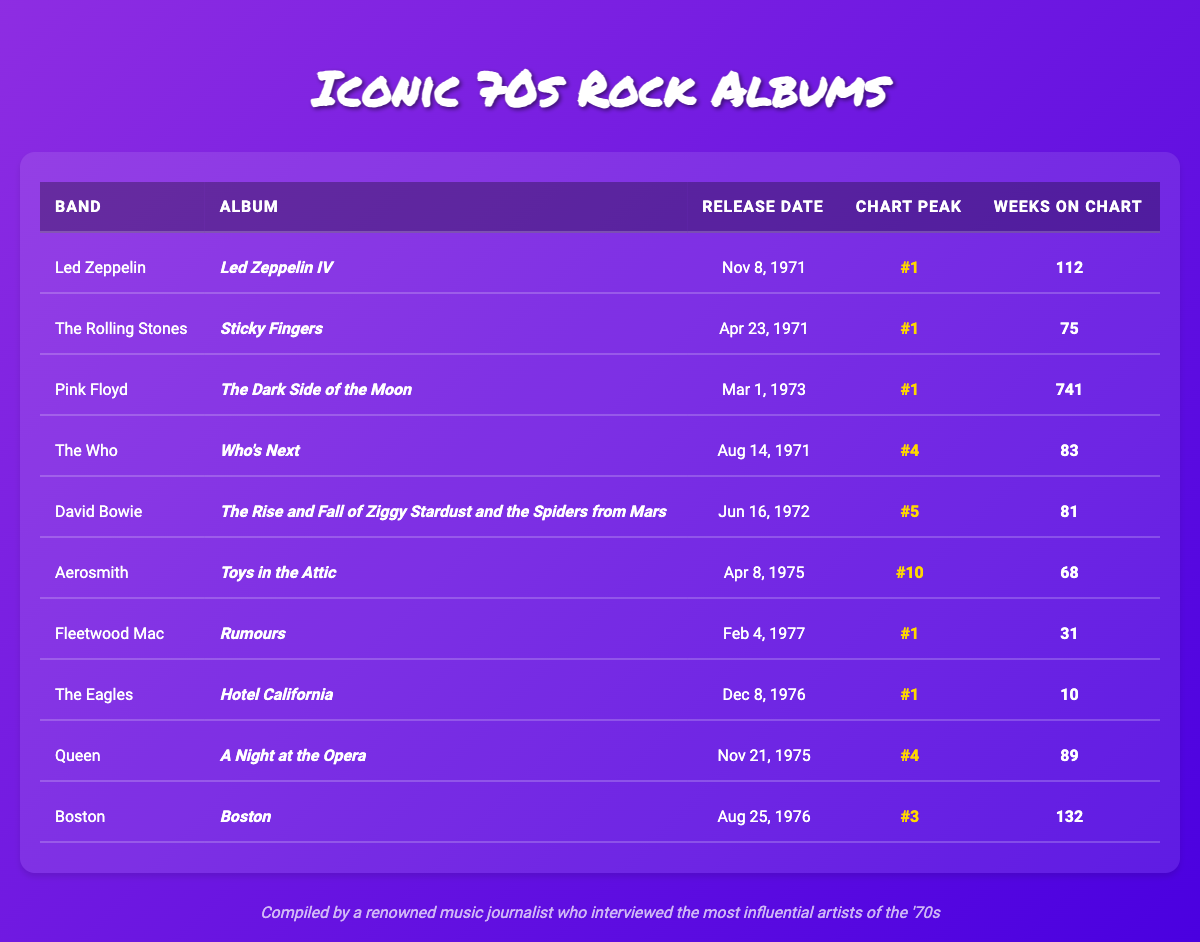What was the release date of Pink Floyd's album "The Dark Side of the Moon"? According to the table, the release date for Pink Floyd's album "The Dark Side of the Moon" is listed as March 1, 1973.
Answer: March 1, 1973 Which album stayed the longest on the charts? The table shows that Pink Floyd's "The Dark Side of the Moon" stayed on the charts for a total of 741 weeks, which is significantly longer than any other album listed.
Answer: 741 weeks Did Fleetwood Mac's "Rumours" peak at number one on the charts? The table indicates that "Rumours" by Fleetwood Mac reached a chart peak of 1, confirming that it did indeed peak at number one.
Answer: Yes How many total weeks did the albums by Led Zeppelin and The Rolling Stones spend on the charts combined? Led Zeppelin's "Led Zeppelin IV" spent 112 weeks and The Rolling Stones' "Sticky Fingers" spent 75 weeks on the chart. Adding them together gives 112 + 75 = 187 weeks.
Answer: 187 weeks Is it true that Aerosmith's "Toys in the Attic" peaked higher than Queen's "A Night at the Opera"? According to the table, Aerosmith's "Toys in the Attic" peaked at number 10, whereas Queen's "A Night at the Opera" peaked at number 4. Since 10 is higher than 4, this statement is false.
Answer: No What is the average peak position of the albums listed from bands that had their albums peak at number one? The albums that peaked at number one are from Led Zeppelin, The Rolling Stones, Pink Floyd, Fleetwood Mac, and The Eagles. Their peak positions are 1, 1, 1, 1, and 1 respectively. The average is (1 + 1 + 1 + 1 + 1) / 5 = 1.
Answer: 1 Which band had an album that peaked at number five and how long did it stay on the charts? David Bowie's album "The Rise and Fall of Ziggy Stardust and the Spiders from Mars" peaked at number 5 and stayed on the charts for 81 weeks as indicated in the table.
Answer: David Bowie, 81 weeks What is the difference in chart weeks between Aerosmith's "Toys in the Attic" and The Who's "Who's Next"? Aerosmith's "Toys in the Attic" stayed on the charts for 68 weeks while The Who's "Who's Next" stayed for 83 weeks. The difference is 83 - 68 = 15 weeks.
Answer: 15 weeks 